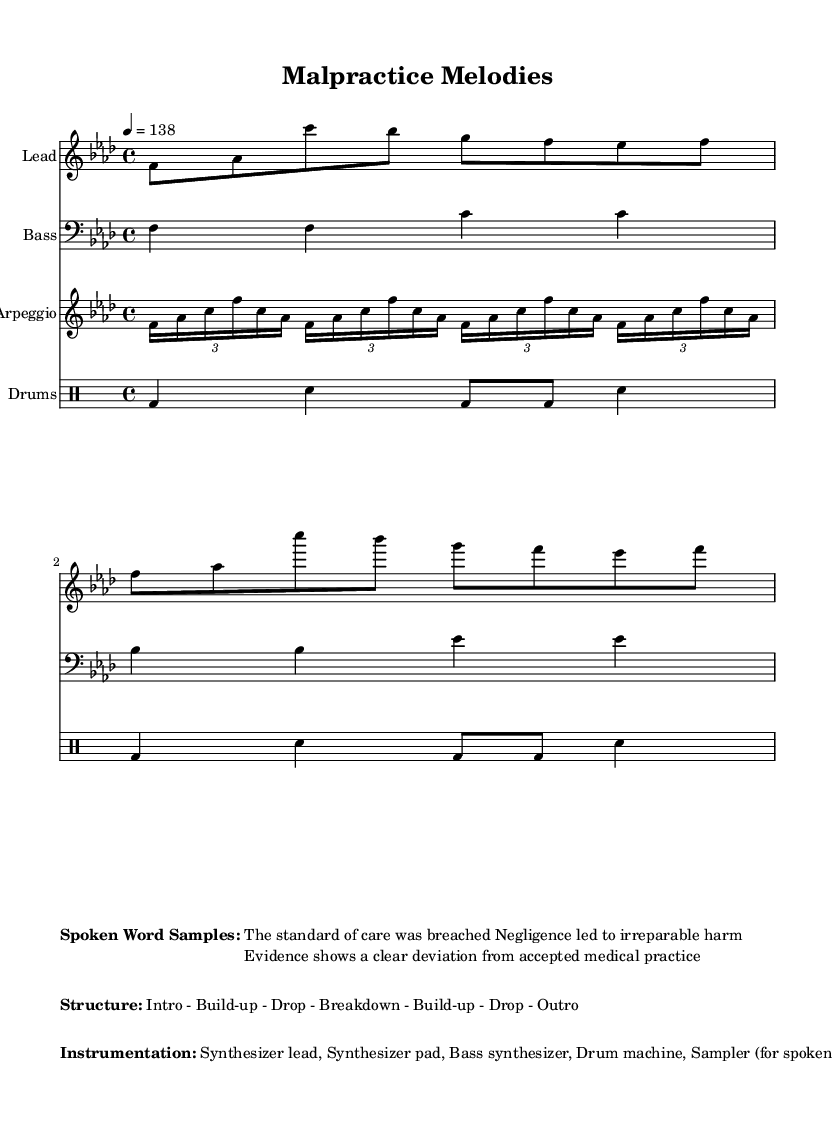What is the key signature of this music? The key signature is indicated at the beginning of the music as it shows F minor, which has four flats (B♭, E♭, A♭, and D♭).
Answer: F minor What is the time signature? The time signature is found at the beginning of the score and is noted as 4/4, which means there are four beats in a measure and the quarter note gets one beat.
Answer: 4/4 What is the tempo marking? The tempo is specified in the score as "4 = 138", indicating that there are 138 beats per minute at the quarter note.
Answer: 138 What instruments are used in the arrangement? The instrumentation is mentioned in the score and includes a synthesizer lead, a synthesizer pad, a bass synthesizer, a drum machine, and a sampler for spoken word samples.
Answer: Synthesizer lead, Synthesizer pad, Bass synthesizer, Drum machine, Sampler What is the structure of this piece? The structure is detailed in the markup section of the score and lists the sections as Intro, Build-up, Drop, Breakdown, Build-up, Drop, and Outro, indicating how the piece progresses throughout.
Answer: Intro - Build-up - Drop - Breakdown - Build-up - Drop - Outro What type of spoken word samples are included? The spoken word samples included in the music relate to medical malpractice and are evidenced in the markup section, specifying lines like "The standard of care was breached."
Answer: Medical malpractice phrases 